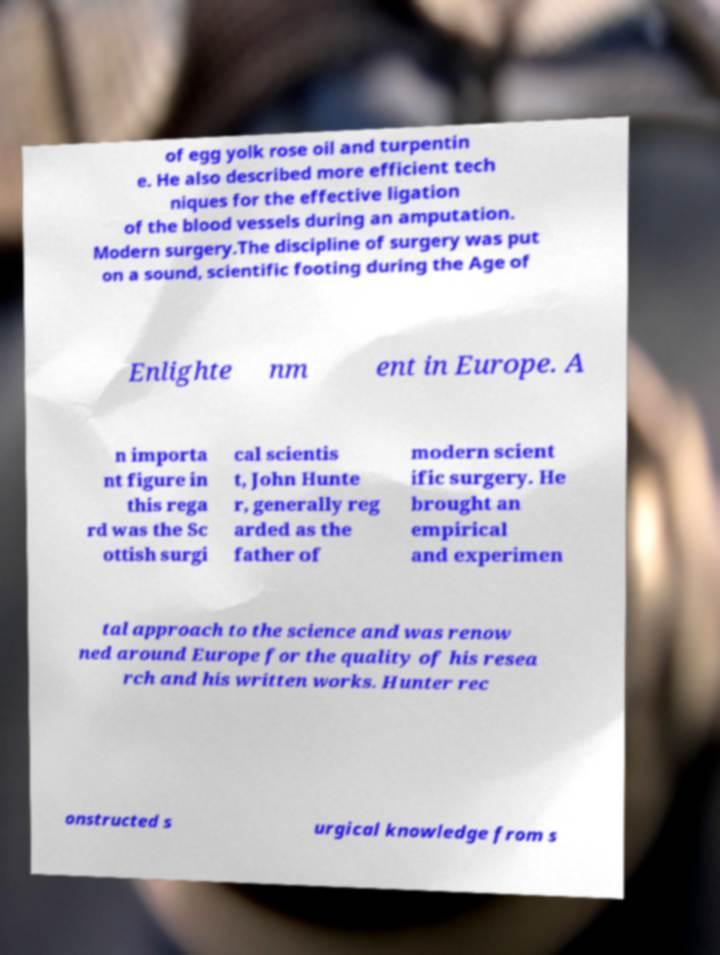Could you extract and type out the text from this image? of egg yolk rose oil and turpentin e. He also described more efficient tech niques for the effective ligation of the blood vessels during an amputation. Modern surgery.The discipline of surgery was put on a sound, scientific footing during the Age of Enlighte nm ent in Europe. A n importa nt figure in this rega rd was the Sc ottish surgi cal scientis t, John Hunte r, generally reg arded as the father of modern scient ific surgery. He brought an empirical and experimen tal approach to the science and was renow ned around Europe for the quality of his resea rch and his written works. Hunter rec onstructed s urgical knowledge from s 